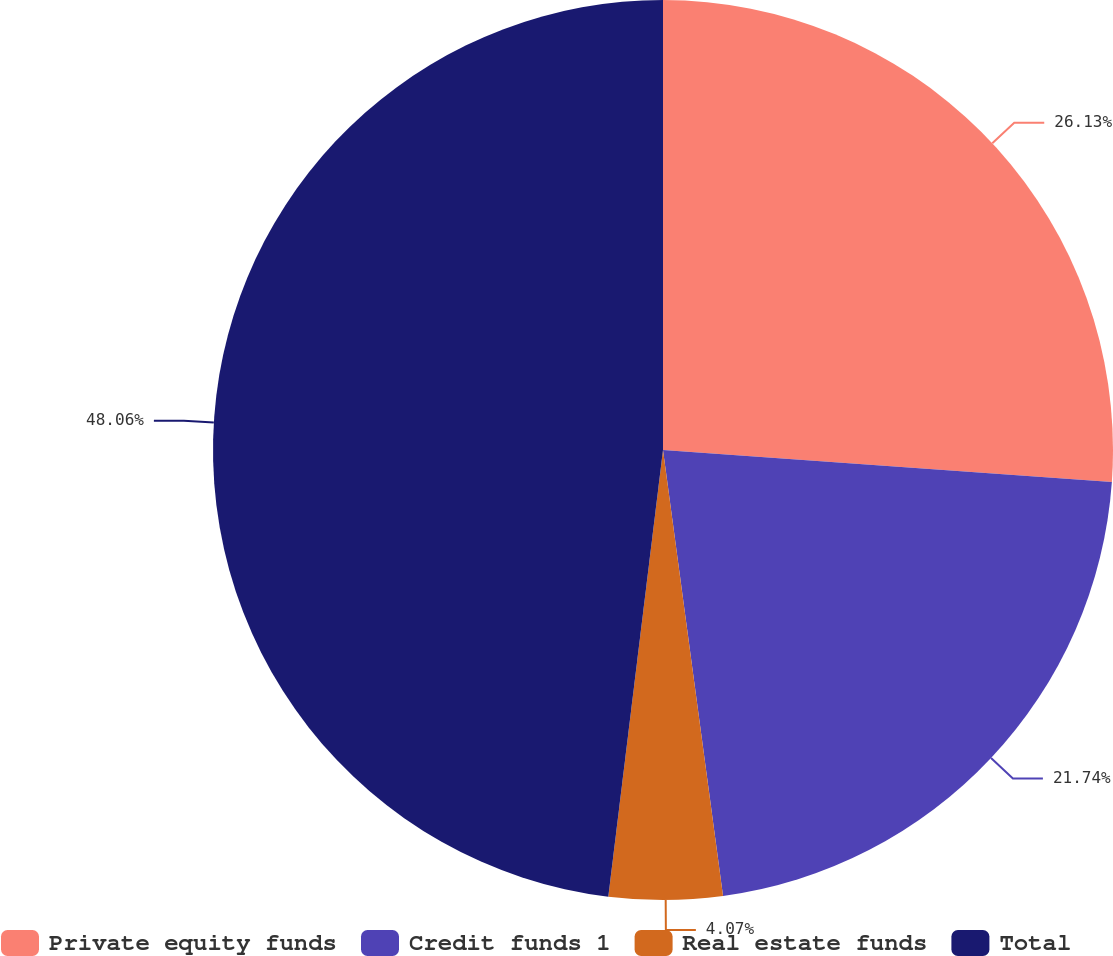Convert chart. <chart><loc_0><loc_0><loc_500><loc_500><pie_chart><fcel>Private equity funds<fcel>Credit funds 1<fcel>Real estate funds<fcel>Total<nl><fcel>26.13%<fcel>21.74%<fcel>4.07%<fcel>48.06%<nl></chart> 